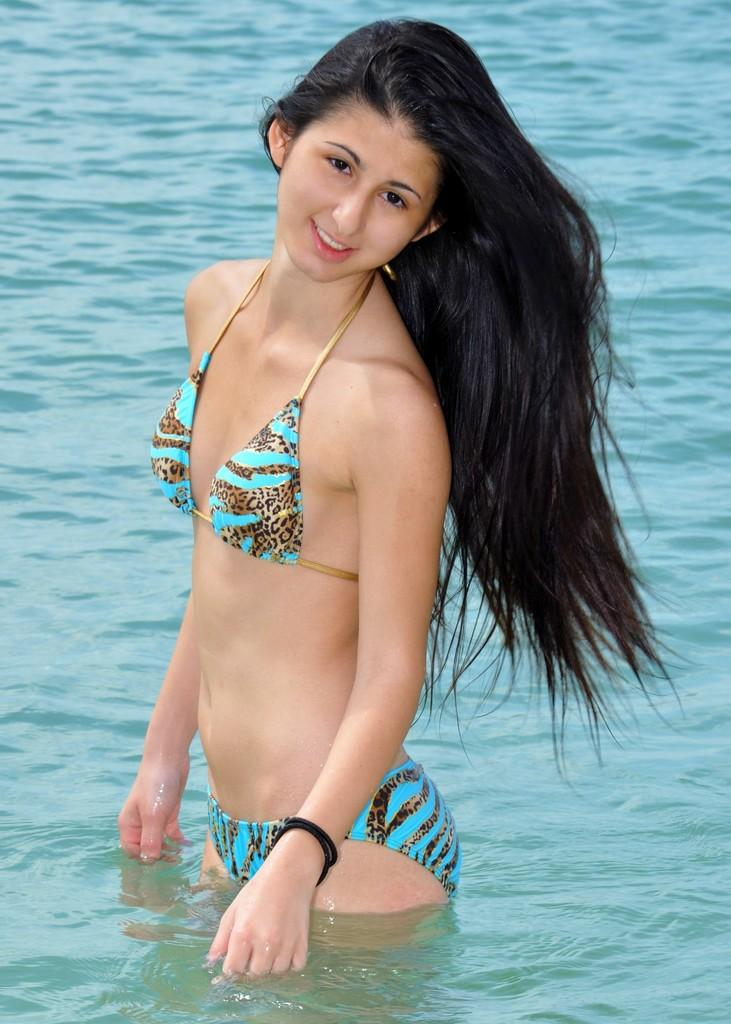Who is present in the image? There is a woman in the image. What is the woman doing in the image? The woman is standing in the water. What is the woman's facial expression in the image? The woman is smiling. What type of car is the woman driving in the image? There is no car present in the image; the woman is standing in the water. What is the condition of the woman's desire in the image? There is no indication of the woman's desire in the image, as it only shows her standing in the water and smiling. 